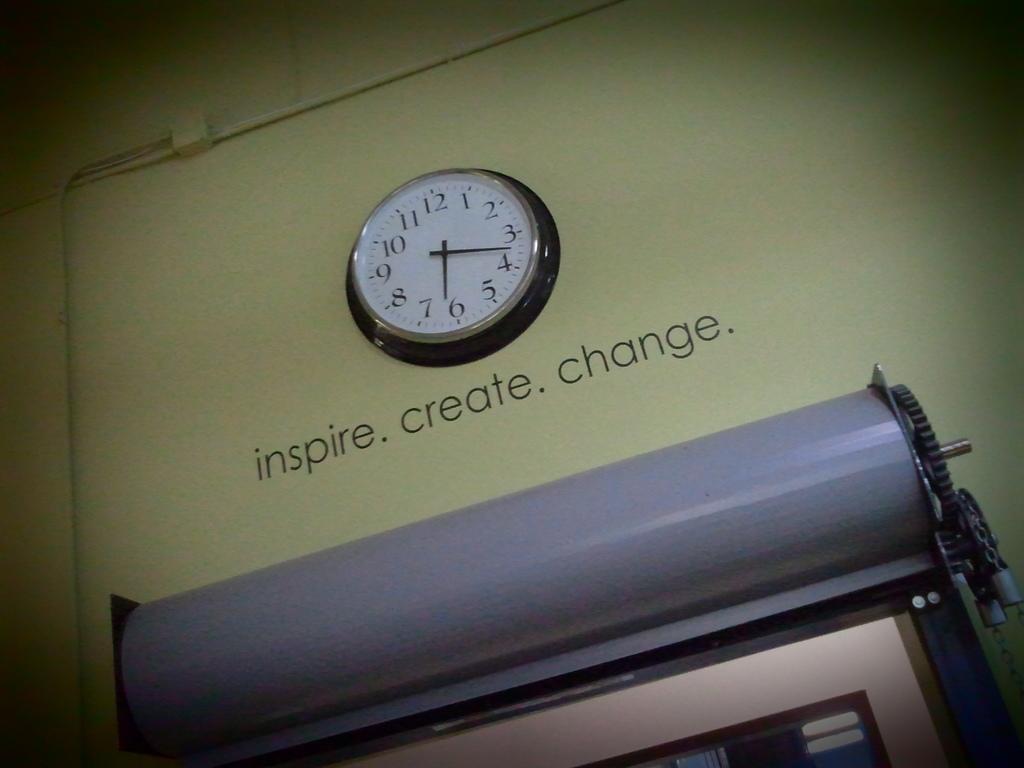What is the inspirational quote?
Provide a succinct answer. Inspire create change. 